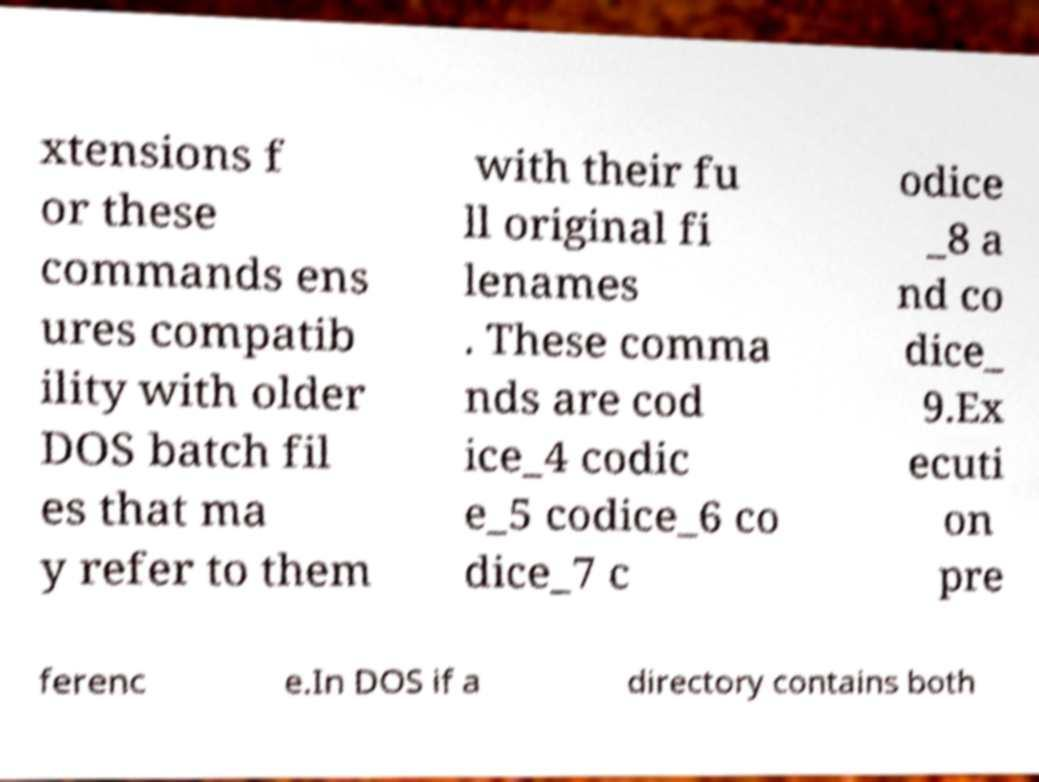Please identify and transcribe the text found in this image. xtensions f or these commands ens ures compatib ility with older DOS batch fil es that ma y refer to them with their fu ll original fi lenames . These comma nds are cod ice_4 codic e_5 codice_6 co dice_7 c odice _8 a nd co dice_ 9.Ex ecuti on pre ferenc e.In DOS if a directory contains both 